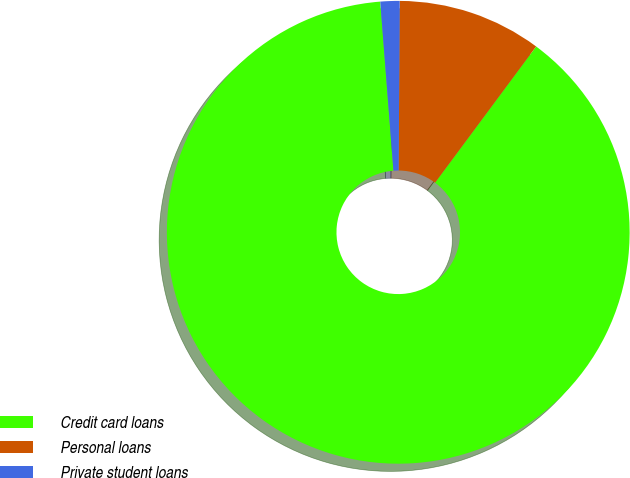Convert chart to OTSL. <chart><loc_0><loc_0><loc_500><loc_500><pie_chart><fcel>Credit card loans<fcel>Personal loans<fcel>Private student loans<nl><fcel>88.6%<fcel>10.06%<fcel>1.34%<nl></chart> 